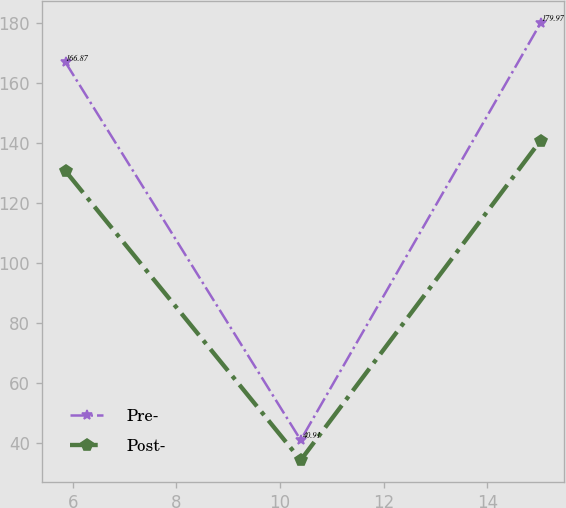Convert chart to OTSL. <chart><loc_0><loc_0><loc_500><loc_500><line_chart><ecel><fcel>Pre-<fcel>Post-<nl><fcel>5.86<fcel>166.87<fcel>130.64<nl><fcel>10.4<fcel>40.91<fcel>34.22<nl><fcel>15.03<fcel>179.97<fcel>140.82<nl></chart> 